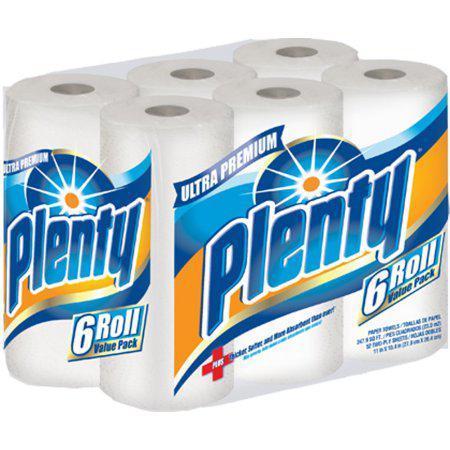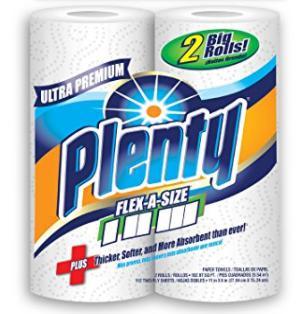The first image is the image on the left, the second image is the image on the right. For the images shown, is this caption "One image shows at least one six-roll multipack of paper towels." true? Answer yes or no. Yes. The first image is the image on the left, the second image is the image on the right. For the images displayed, is the sentence "There is exactly one paper towel roll in the left image" factually correct? Answer yes or no. No. 